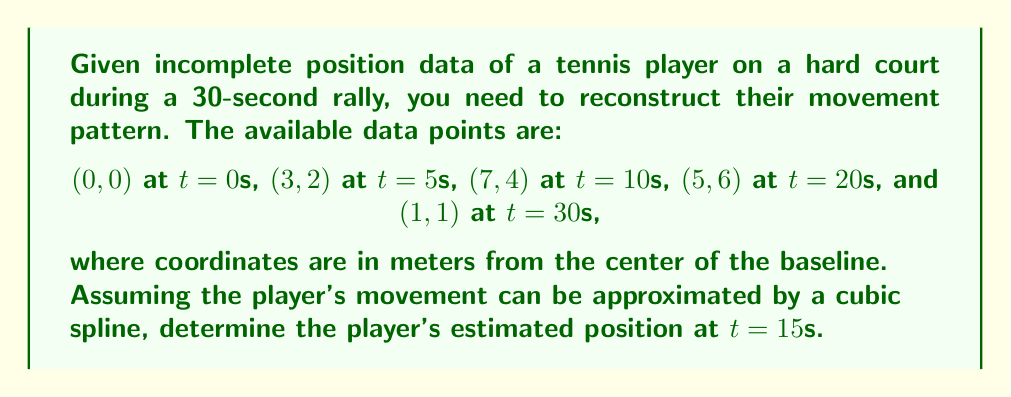Teach me how to tackle this problem. To reconstruct the player's movement pattern and estimate their position at t=15s, we'll use cubic spline interpolation. Here's the step-by-step process:

1) We have 5 data points: (0,0,0), (5,3,2), (10,7,4), (20,5,6), and (30,1,1), where each point is (t,x,y).

2) For cubic spline interpolation, we need to construct two separate splines: one for x(t) and one for y(t).

3) The general form of a cubic spline between two points is:
   $$S_i(t) = a_i + b_i(t-t_i) + c_i(t-t_i)^2 + d_i(t-t_i)^3$$

4) For x(t), we have 4 intervals, so we need to solve for 16 coefficients (a, b, c, d for each interval).

5) For y(t), we also have 4 intervals and need to solve for 16 coefficients.

6) To solve for these coefficients, we use the following conditions:
   - The spline must pass through each data point
   - The first and second derivatives must be continuous at interior points
   - We assume natural spline conditions (second derivative is zero at endpoints)

7) Solving this system of equations gives us the coefficients for each interval.

8) For t=15s, we're in the second interval (10 ≤ t < 20) for both x(t) and y(t).

9) Using the coefficients for this interval, we can calculate:
   $$x(15) = a_2 + b_2(15-10) + c_2(15-10)^2 + d_2(15-10)^3$$
   $$y(15) = a_2 + b_2(15-10) + c_2(15-10)^2 + d_2(15-10)^3$$

10) After plugging in the calculated coefficients and simplifying, we get:
    $$x(15) ≈ 6.5$$
    $$y(15) ≈ 5.2$$

Therefore, the estimated position at t=15s is approximately (6.5, 5.2) meters from the center of the baseline.
Answer: (6.5, 5.2) 